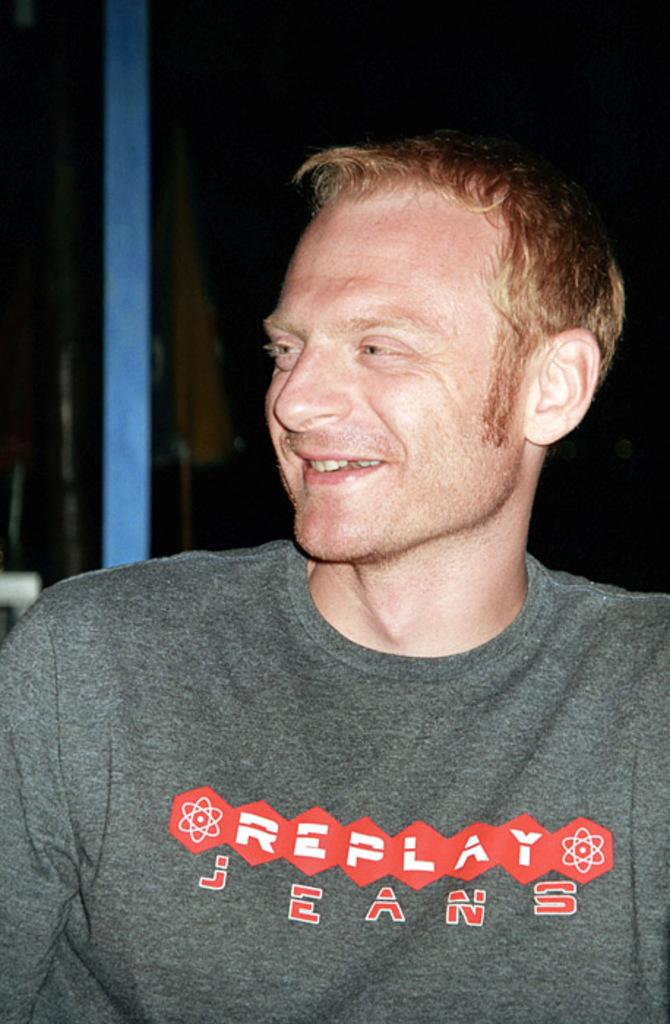Who is present in the image? There is a person in the image. What is the person's expression? The person is smiling. What can be seen attached to the pole in the image? There is a flag attached to the pole in the image. What is the color of the background in the image? The background of the image is dark. What type of road can be seen in the image? There is no road present in the image. What is the zephyr doing in the image? There is no zephyr present in the image. 